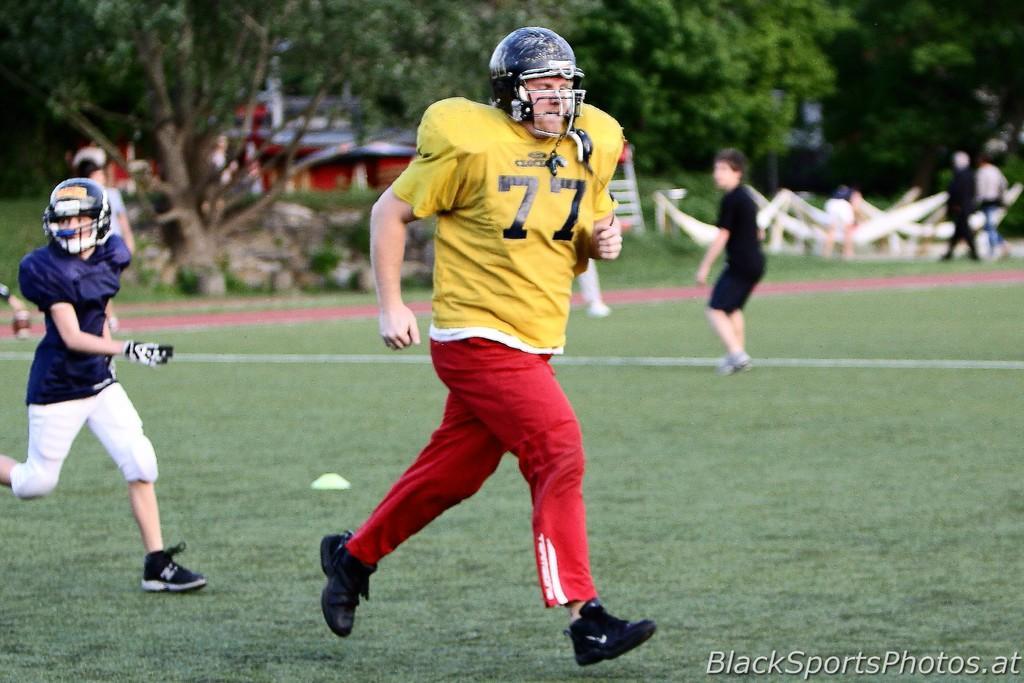How would you summarize this image in a sentence or two? In this image in front there are two players running on the grass. Behind them there are few other people. In the background of the image there are trees, buildings, rocks. On the right side of the image there are few objects. There is some text on the bottom of the image. 